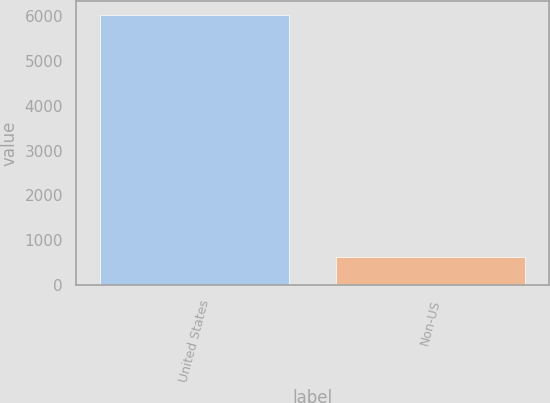Convert chart. <chart><loc_0><loc_0><loc_500><loc_500><bar_chart><fcel>United States<fcel>Non-US<nl><fcel>6040<fcel>634<nl></chart> 